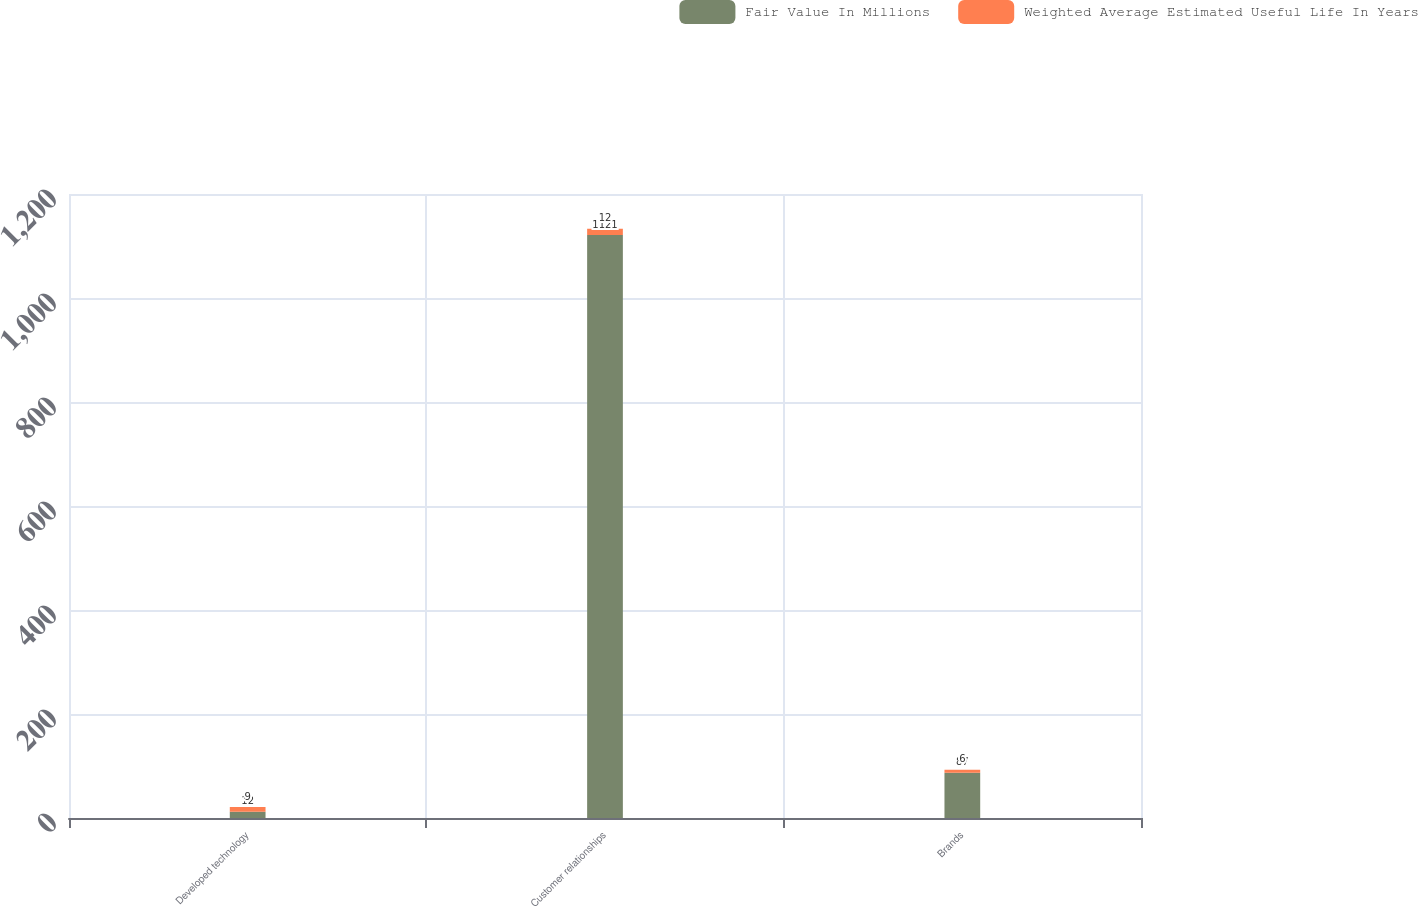Convert chart to OTSL. <chart><loc_0><loc_0><loc_500><loc_500><stacked_bar_chart><ecel><fcel>Developed technology<fcel>Customer relationships<fcel>Brands<nl><fcel>Fair Value In Millions<fcel>12<fcel>1121<fcel>87<nl><fcel>Weighted Average Estimated Useful Life In Years<fcel>9<fcel>12<fcel>6<nl></chart> 